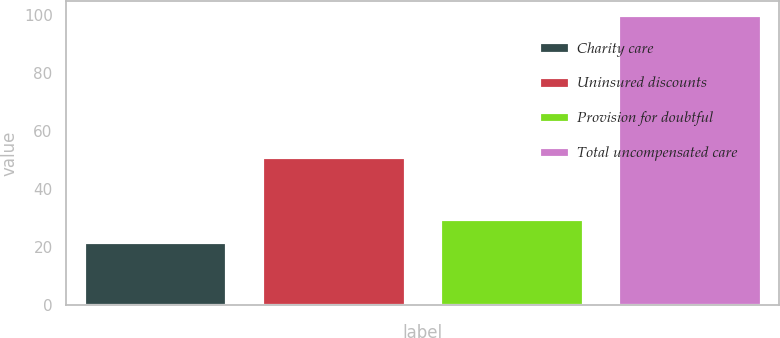Convert chart to OTSL. <chart><loc_0><loc_0><loc_500><loc_500><bar_chart><fcel>Charity care<fcel>Uninsured discounts<fcel>Provision for doubtful<fcel>Total uncompensated care<nl><fcel>22<fcel>51<fcel>29.8<fcel>100<nl></chart> 